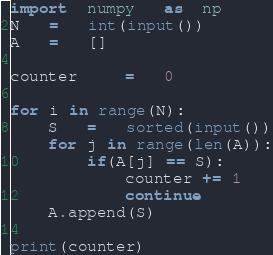Convert code to text. <code><loc_0><loc_0><loc_500><loc_500><_Python_>import  numpy   as  np
N   =   int(input())
A   =   []

counter     =   0

for i in range(N):
    S   =   sorted(input())
    for j in range(len(A)):
        if(A[j] == S):
            counter += 1
            continue
    A.append(S)

print(counter)</code> 